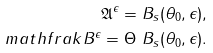<formula> <loc_0><loc_0><loc_500><loc_500>\mathfrak { A } ^ { \epsilon } = B _ { s } ( \theta _ { 0 } , \epsilon ) , \\ m a t h f r a k { B } ^ { \epsilon } = \Theta \ B _ { s } ( \theta _ { 0 } , \epsilon ) .</formula> 